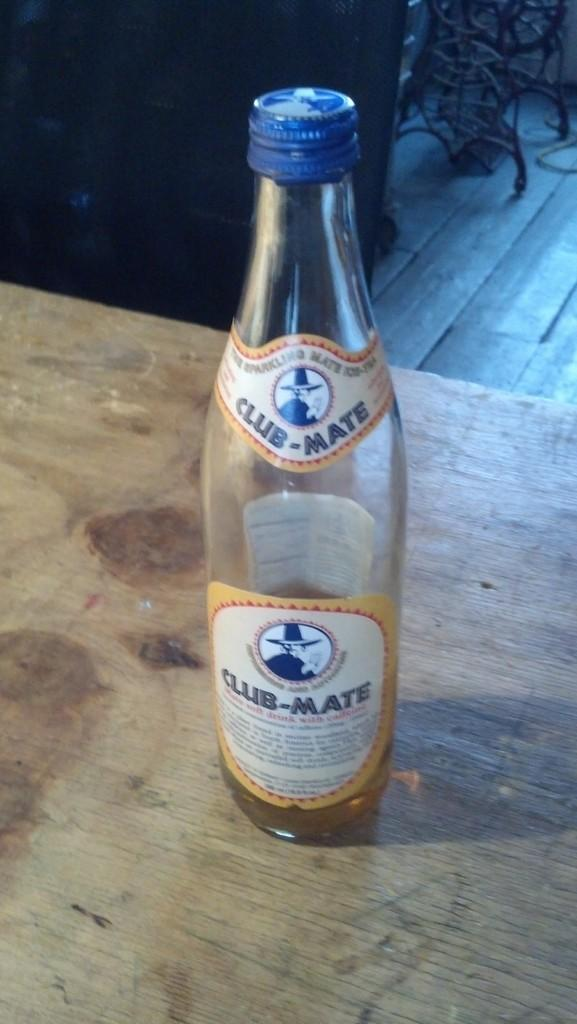<image>
Share a concise interpretation of the image provided. A bottle of club-mate resting in a table. 